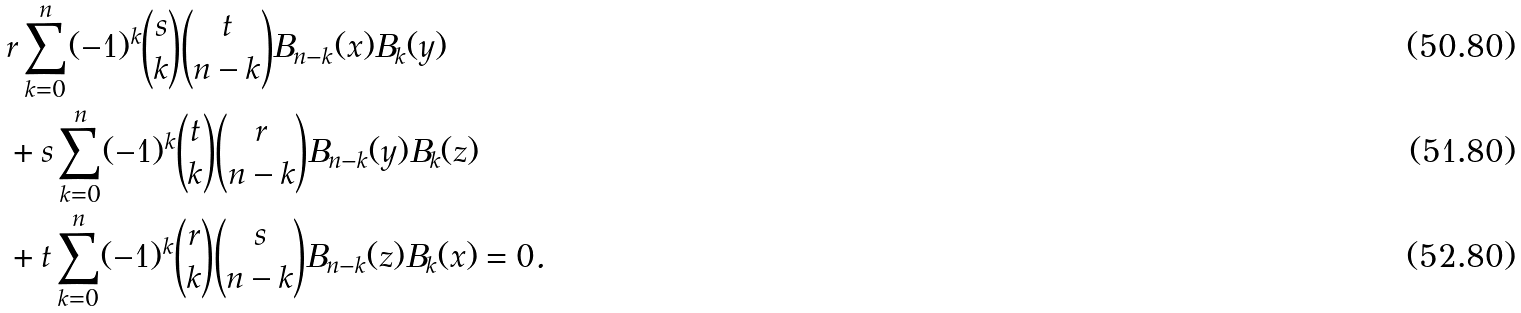Convert formula to latex. <formula><loc_0><loc_0><loc_500><loc_500>& r \sum _ { k = 0 } ^ { n } ( - 1 ) ^ { k } { s \choose k } { t \choose n - k } B _ { n - k } ( x ) B _ { k } ( y ) \\ & + s \sum _ { k = 0 } ^ { n } ( - 1 ) ^ { k } { t \choose k } { r \choose n - k } B _ { n - k } ( y ) B _ { k } ( z ) \\ & + t \sum _ { k = 0 } ^ { n } ( - 1 ) ^ { k } { r \choose k } { s \choose n - k } B _ { n - k } ( z ) B _ { k } ( x ) = 0 .</formula> 